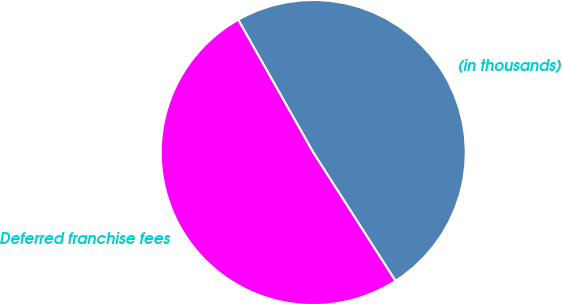<chart> <loc_0><loc_0><loc_500><loc_500><pie_chart><fcel>(in thousands)<fcel>Deferred franchise fees<nl><fcel>49.13%<fcel>50.87%<nl></chart> 